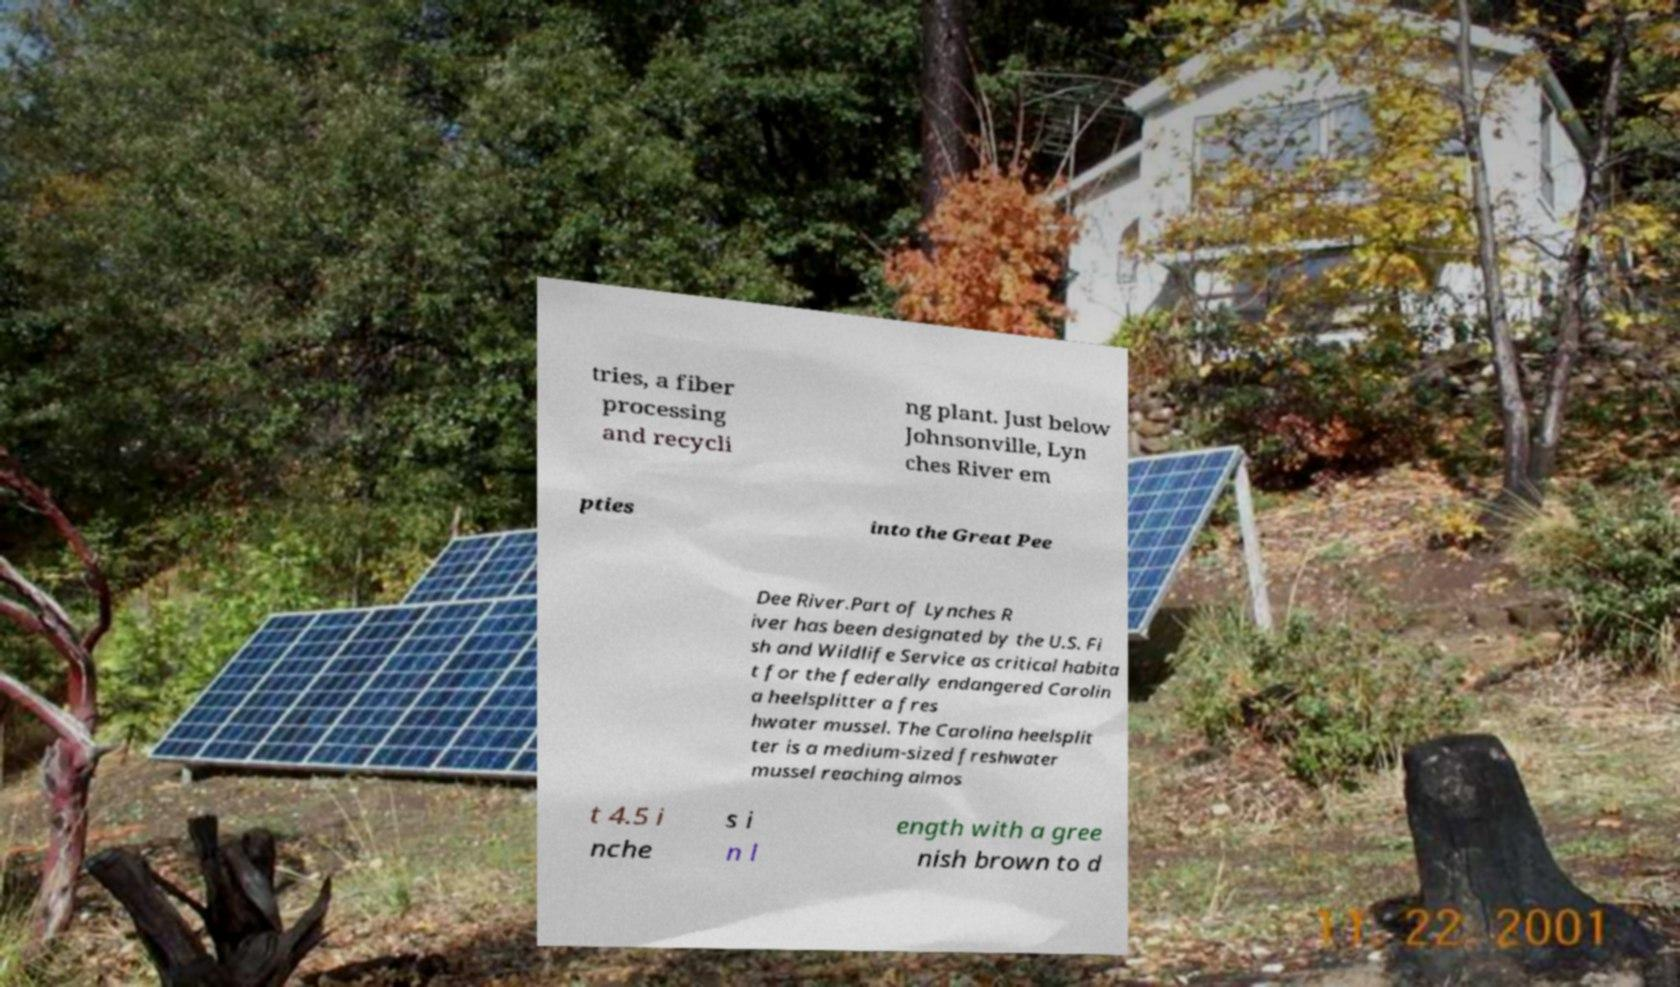Could you assist in decoding the text presented in this image and type it out clearly? tries, a fiber processing and recycli ng plant. Just below Johnsonville, Lyn ches River em pties into the Great Pee Dee River.Part of Lynches R iver has been designated by the U.S. Fi sh and Wildlife Service as critical habita t for the federally endangered Carolin a heelsplitter a fres hwater mussel. The Carolina heelsplit ter is a medium-sized freshwater mussel reaching almos t 4.5 i nche s i n l ength with a gree nish brown to d 